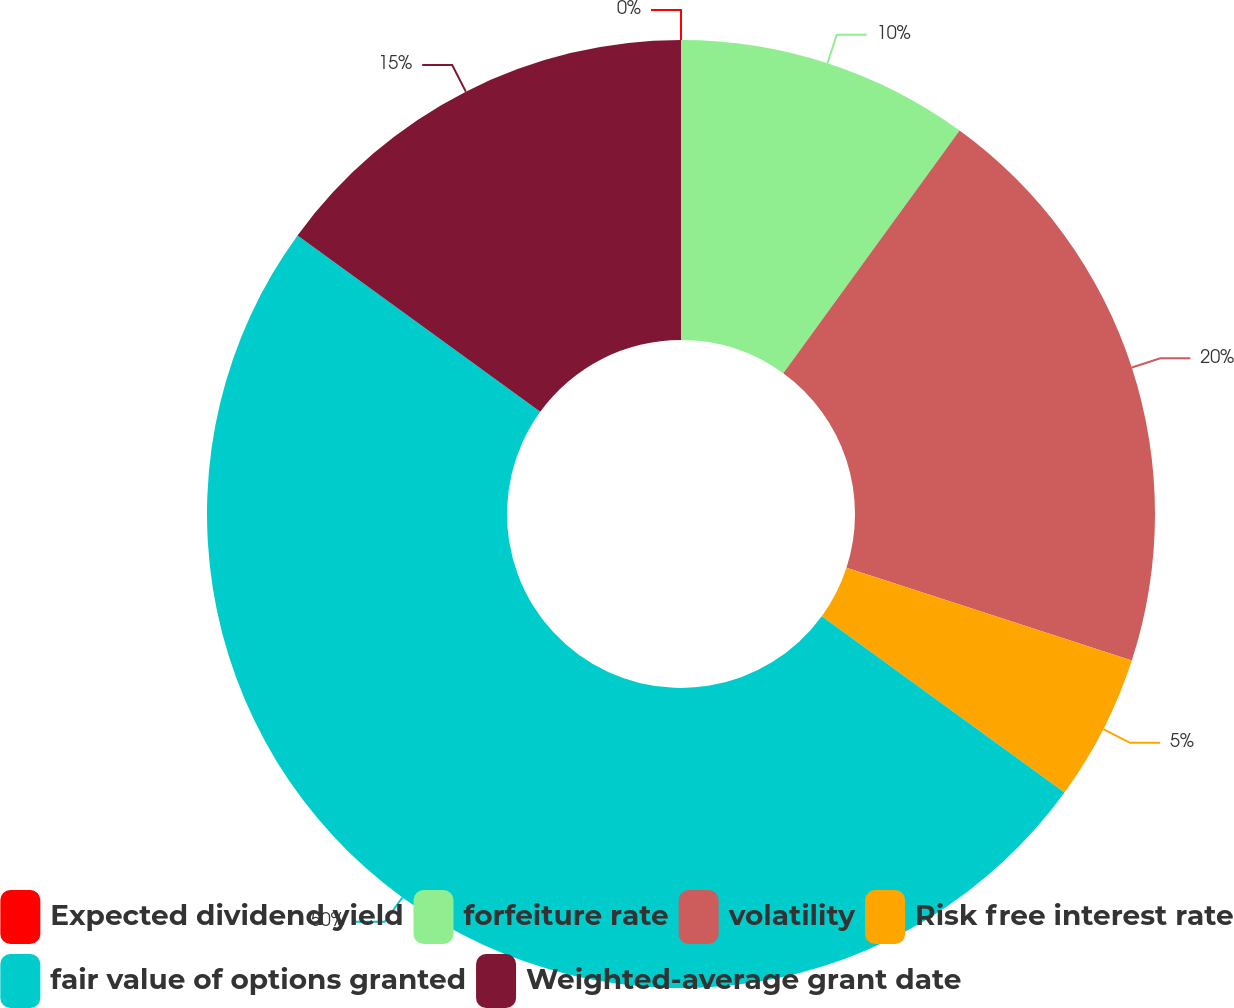Convert chart to OTSL. <chart><loc_0><loc_0><loc_500><loc_500><pie_chart><fcel>Expected dividend yield<fcel>forfeiture rate<fcel>volatility<fcel>Risk free interest rate<fcel>fair value of options granted<fcel>Weighted-average grant date<nl><fcel>0.0%<fcel>10.0%<fcel>20.0%<fcel>5.0%<fcel>50.0%<fcel>15.0%<nl></chart> 